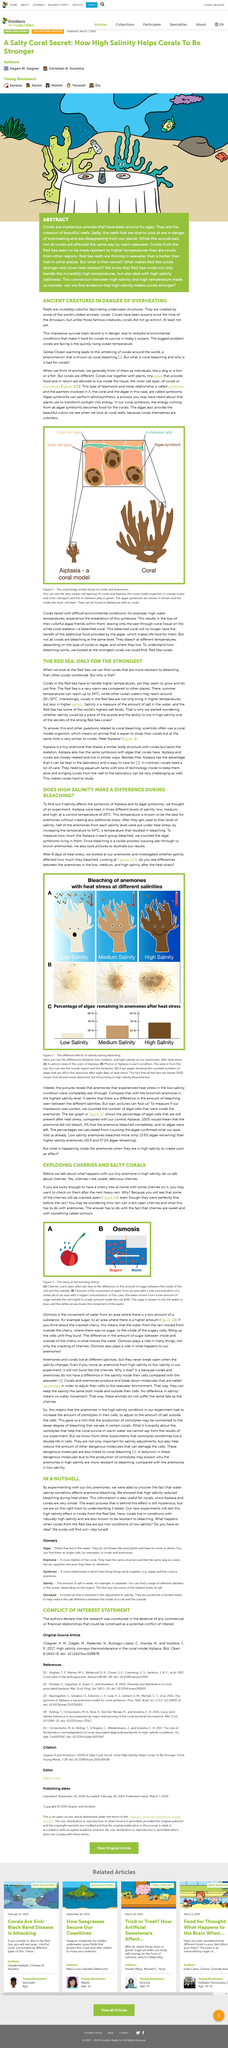Draw attention to some important aspects in this diagram. After exposure to both heat stress and high salinity, the remaining algae in anemones was found to be approximately 40%. This is significantly lower than what would be expected in the presence of high salinity alone, as it was found that high salinity decreased the bleaching of algae. Osmosis is the process by which water from a region of low concentration of a solute moves to a region of higher concentration, in order to equalize the concentration on both sides of a semipermeable membrane. The experiment revealed that a temperature of 34 degrees Celsius resulted in bleaching. Global ocean warming is causing corals to undergo a change in color, resulting in their whitening. In the summer, typical sea temperatures may reach around 29 to 32 degrees Celsius, which is considered warm. 